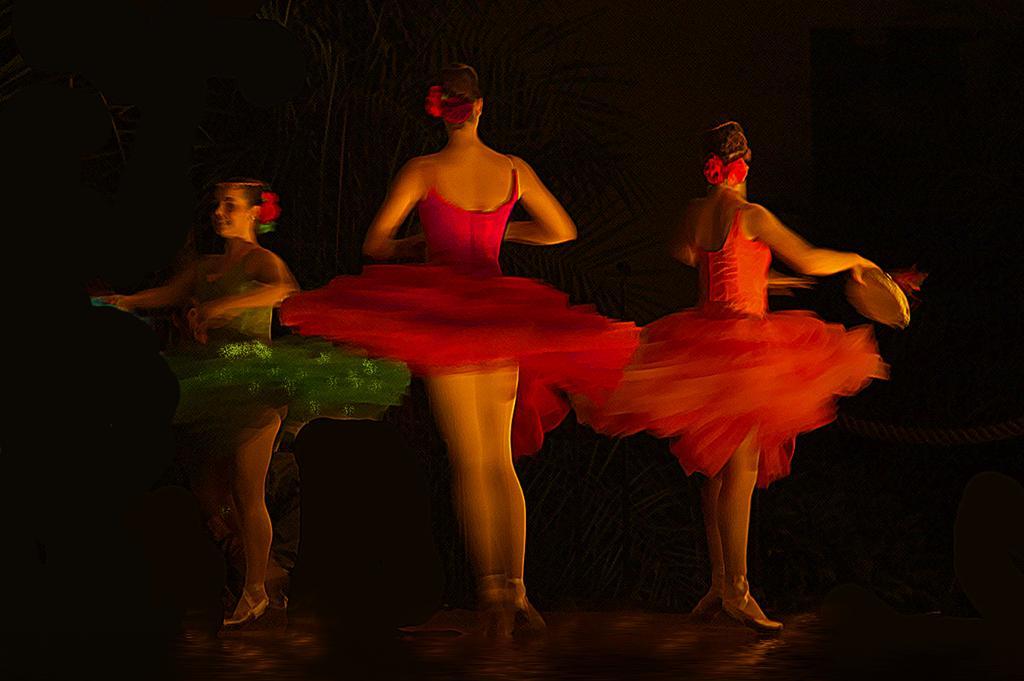Could you give a brief overview of what you see in this image? Here in this picture we can see three women dancing on the floor over there and all of them are wearing different colored frogs on them and the woman on the right side is holding something in her hand over there. 